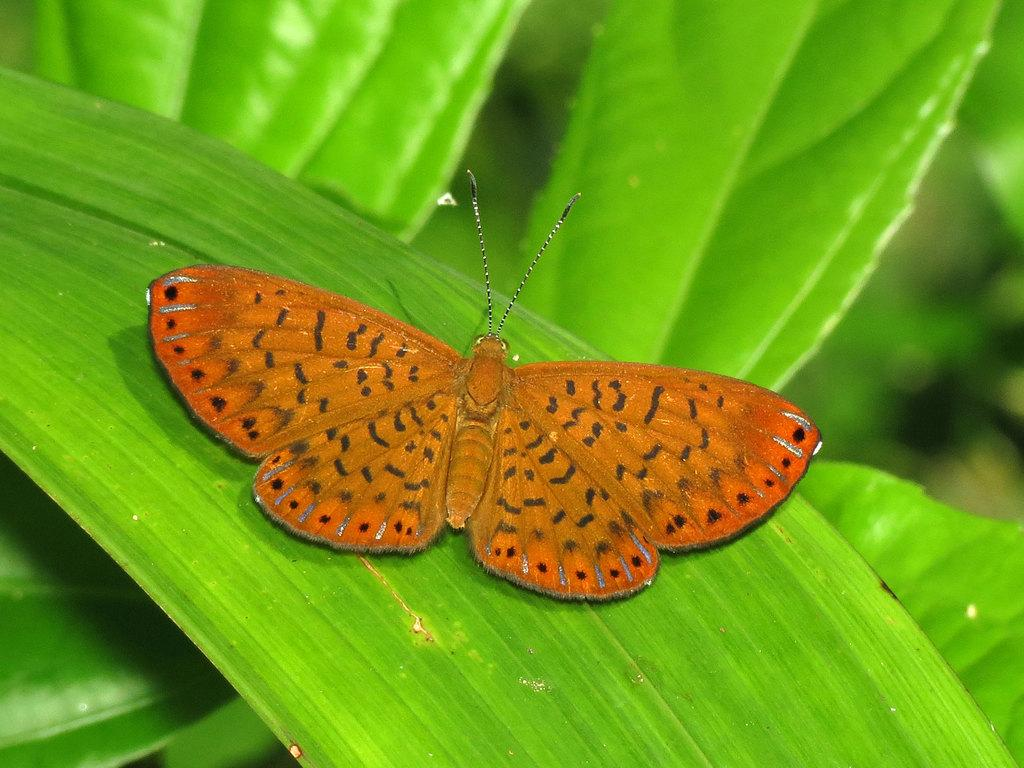What is the main subject of the image? There is a butterfly in the image. Where is the butterfly located in the image? The butterfly is on a leaf. What else can be seen in the image besides the butterfly? There are leaves visible in the image. What type of paint is being used by the butterfly to color the leaves in the image? There is no paint or indication of painting in the image; the butterfly is simply resting on a leaf. 